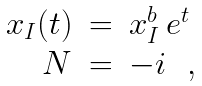<formula> <loc_0><loc_0><loc_500><loc_500>\begin{array} { r c l } x _ { I } ( t ) & = & x _ { I } ^ { b } \, e ^ { t } \\ N & = & - i \ \ , \end{array}</formula> 